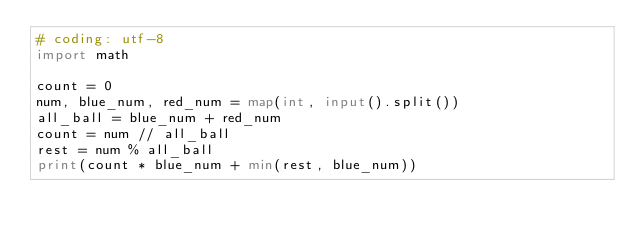<code> <loc_0><loc_0><loc_500><loc_500><_Python_># coding: utf-8
import math

count = 0
num, blue_num, red_num = map(int, input().split())
all_ball = blue_num + red_num
count = num // all_ball
rest = num % all_ball
print(count * blue_num + min(rest, blue_num))
</code> 